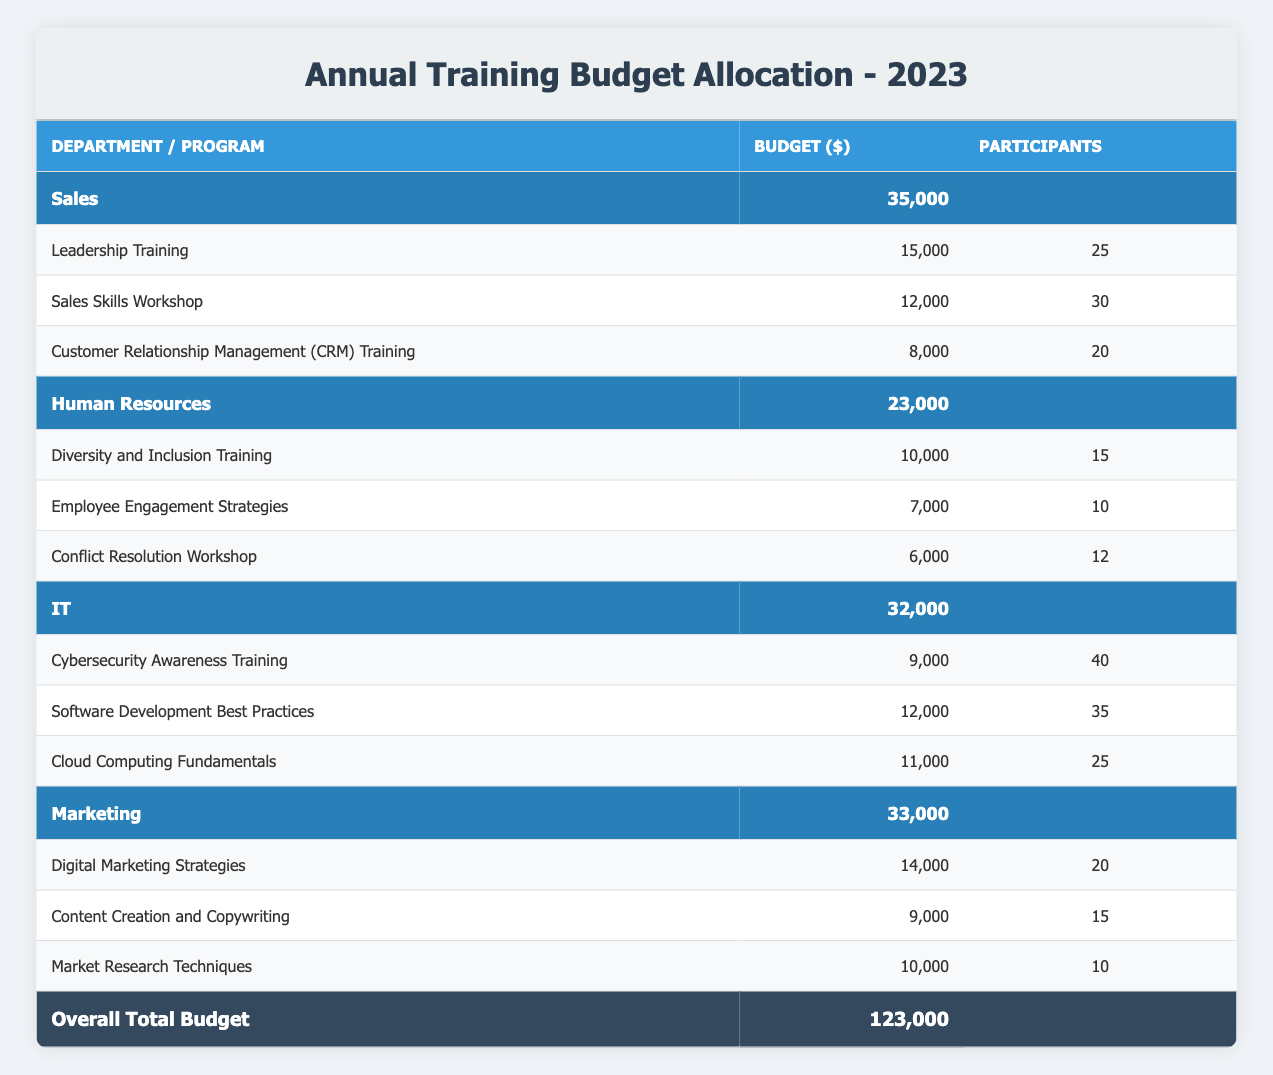What is the total budget allocated for the IT department? The IT department's total budget is listed as 32,000 in the table.
Answer: 32,000 How many participants are attending the Leadership Training program? The Leadership Training program in the Sales department has 25 participants as specified in the table.
Answer: 25 Which department has the highest total budget allocation? By comparing the total budget allocations, Sales has 35,000 which is the highest among the departments.
Answer: Sales What is the combined budget for all the programs in Human Resources? The budget for the programs in Human Resources are 10,000 + 7,000 + 6,000 = 23,000, which matches the total department budget.
Answer: 23,000 Is it true that the Cybersecurity Awareness Training has more participants than the Digital Marketing Strategies program? The Cybersecurity Awareness Training has 40 participants while the Digital Marketing Strategies has 20 participants. Therefore, the statement is true.
Answer: Yes What is the average number of participants per program in the Marketing department? The total number of participants is 20 + 15 + 10 = 45. There are 3 programs, so the average is 45/3 = 15.
Answer: 15 If the Marketing department's budget is increased by 10 percent, what will be the new total budget? The current total budget for Marketing is 33,000. A 10 percent increase is calculated as 33,000 * 0.10 = 3,300, resulting in an updated budget of 33,000 + 3,300 = 36,300.
Answer: 36,300 How much budget is allocated for the Customer Relationship Management (CRM) Training program? The budget for the Customer Relationship Management (CRM) Training is listed as 8,000.
Answer: 8,000 Which program in the IT department has the highest budget allocation? Among the IT programs, Software Development Best Practices is the highest at 12,000.
Answer: Software Development Best Practices 